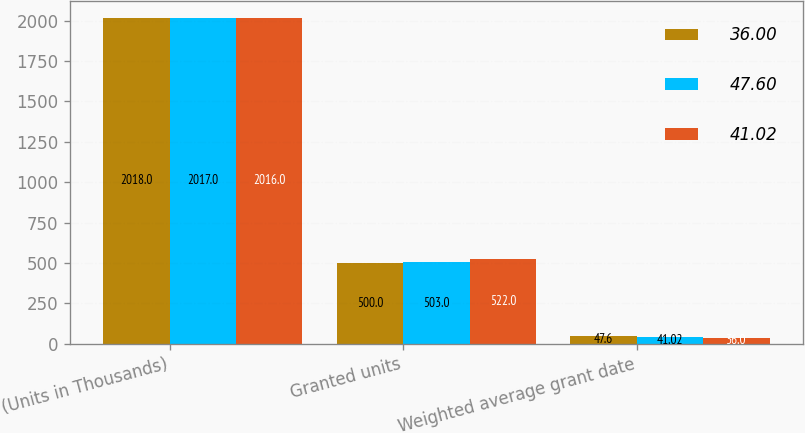<chart> <loc_0><loc_0><loc_500><loc_500><stacked_bar_chart><ecel><fcel>(Units in Thousands)<fcel>Granted units<fcel>Weighted average grant date<nl><fcel>36<fcel>2018<fcel>500<fcel>47.6<nl><fcel>47.6<fcel>2017<fcel>503<fcel>41.02<nl><fcel>41.02<fcel>2016<fcel>522<fcel>36<nl></chart> 